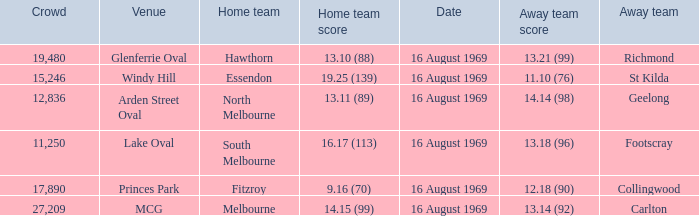What was the away team when the game was at Princes Park? Collingwood. 